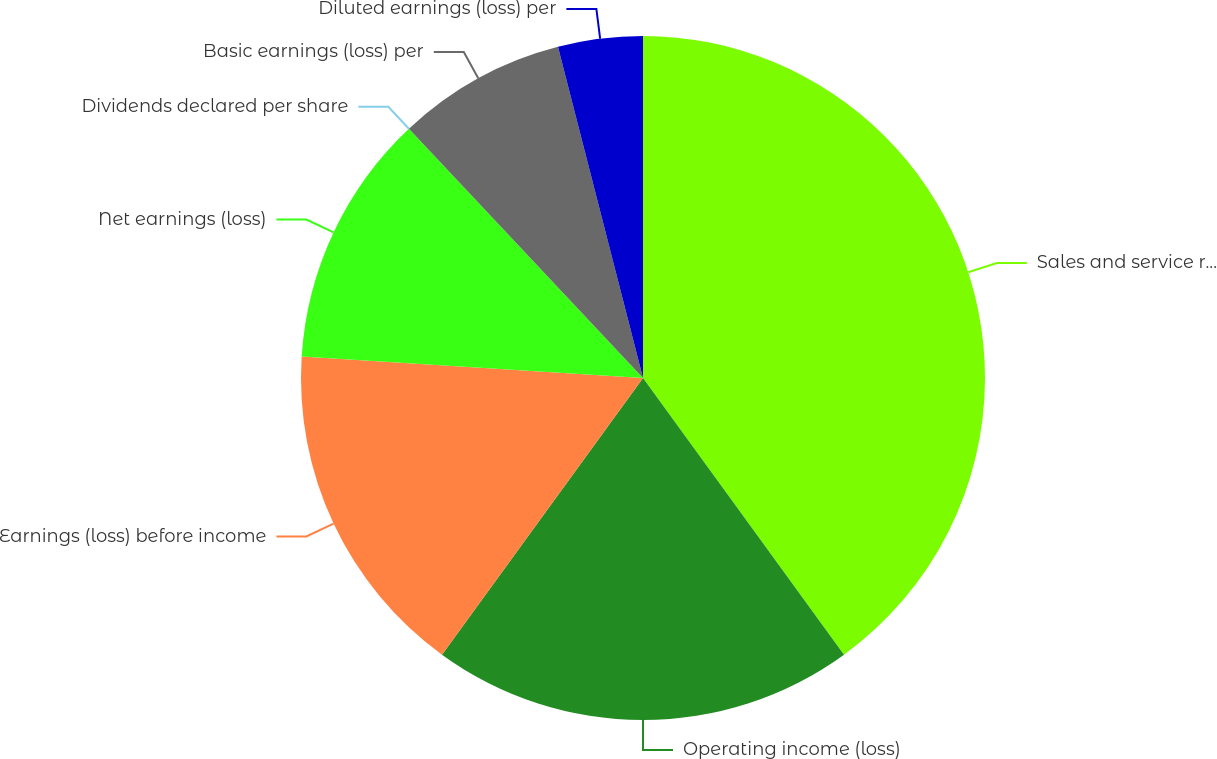Convert chart. <chart><loc_0><loc_0><loc_500><loc_500><pie_chart><fcel>Sales and service revenues<fcel>Operating income (loss)<fcel>Earnings (loss) before income<fcel>Net earnings (loss)<fcel>Dividends declared per share<fcel>Basic earnings (loss) per<fcel>Diluted earnings (loss) per<nl><fcel>40.0%<fcel>20.0%<fcel>16.0%<fcel>12.0%<fcel>0.0%<fcel>8.0%<fcel>4.0%<nl></chart> 